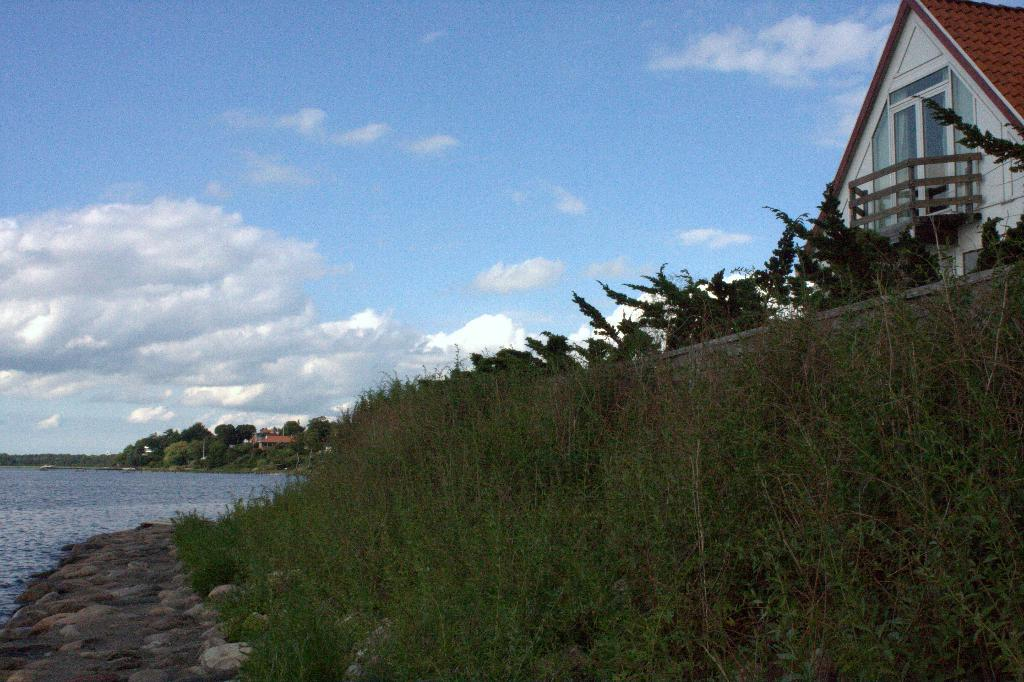What type of natural elements can be seen in the image? There are trees and plants visible in the image. What type of man-made structures are present in the image? There are buildings in the image. What is the condition of the water in the image? The water is visible in the image. How would you describe the sky in the image? The sky is blue and cloudy in the image. How much quicksand is present in the image? There is no quicksand present in the image. What type of tray is being used to serve the plants in the image? There is no tray visible in the image; the plants are not being served on a tray. 